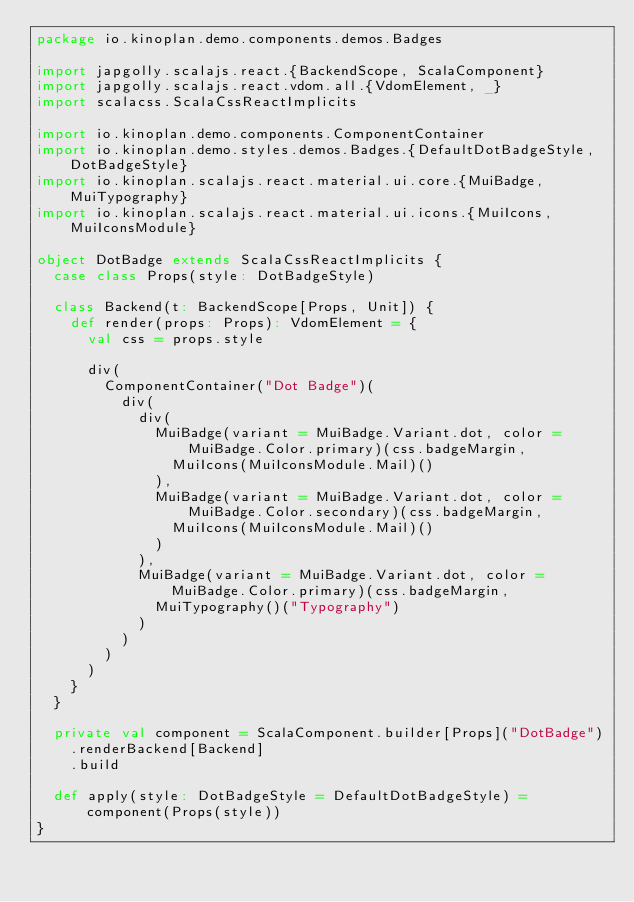<code> <loc_0><loc_0><loc_500><loc_500><_Scala_>package io.kinoplan.demo.components.demos.Badges

import japgolly.scalajs.react.{BackendScope, ScalaComponent}
import japgolly.scalajs.react.vdom.all.{VdomElement, _}
import scalacss.ScalaCssReactImplicits

import io.kinoplan.demo.components.ComponentContainer
import io.kinoplan.demo.styles.demos.Badges.{DefaultDotBadgeStyle, DotBadgeStyle}
import io.kinoplan.scalajs.react.material.ui.core.{MuiBadge, MuiTypography}
import io.kinoplan.scalajs.react.material.ui.icons.{MuiIcons, MuiIconsModule}

object DotBadge extends ScalaCssReactImplicits {
  case class Props(style: DotBadgeStyle)

  class Backend(t: BackendScope[Props, Unit]) {
    def render(props: Props): VdomElement = {
      val css = props.style

      div(
        ComponentContainer("Dot Badge")(
          div(
            div(
              MuiBadge(variant = MuiBadge.Variant.dot, color = MuiBadge.Color.primary)(css.badgeMargin,
                MuiIcons(MuiIconsModule.Mail)()
              ),
              MuiBadge(variant = MuiBadge.Variant.dot, color = MuiBadge.Color.secondary)(css.badgeMargin,
                MuiIcons(MuiIconsModule.Mail)()
              )
            ),
            MuiBadge(variant = MuiBadge.Variant.dot, color = MuiBadge.Color.primary)(css.badgeMargin,
              MuiTypography()("Typography")
            )
          )
        )
      )
    }
  }

  private val component = ScalaComponent.builder[Props]("DotBadge")
    .renderBackend[Backend]
    .build

  def apply(style: DotBadgeStyle = DefaultDotBadgeStyle) = component(Props(style))
}
</code> 